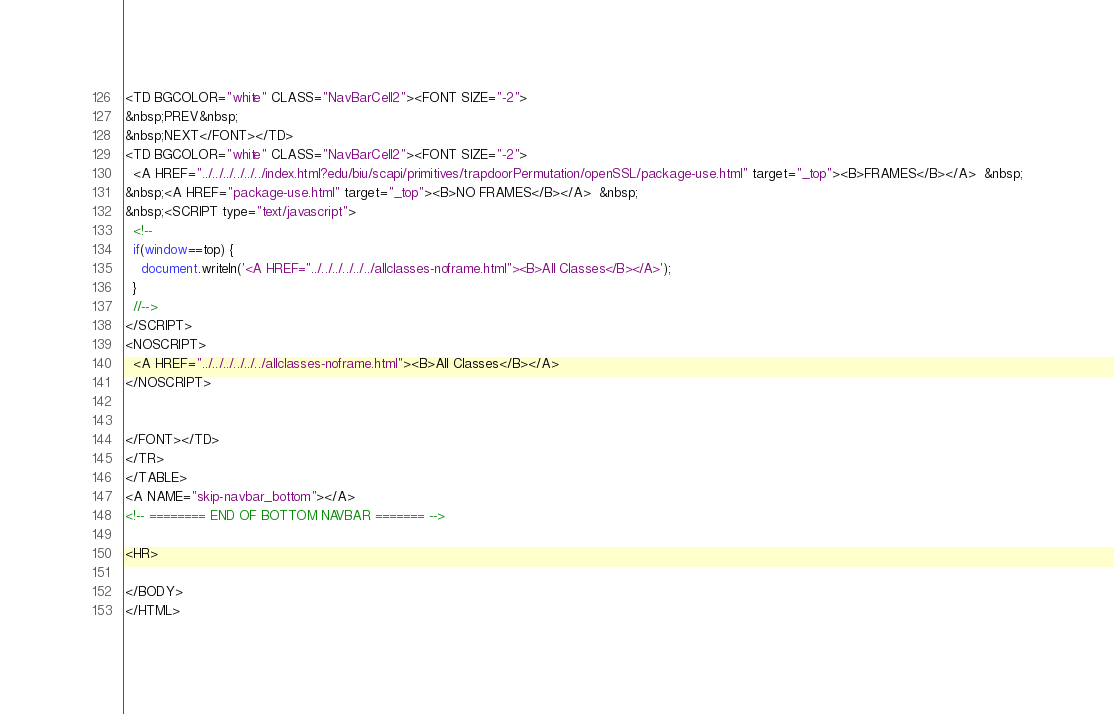<code> <loc_0><loc_0><loc_500><loc_500><_HTML_><TD BGCOLOR="white" CLASS="NavBarCell2"><FONT SIZE="-2">
&nbsp;PREV&nbsp;
&nbsp;NEXT</FONT></TD>
<TD BGCOLOR="white" CLASS="NavBarCell2"><FONT SIZE="-2">
  <A HREF="../../../../../../index.html?edu/biu/scapi/primitives/trapdoorPermutation/openSSL/package-use.html" target="_top"><B>FRAMES</B></A>  &nbsp;
&nbsp;<A HREF="package-use.html" target="_top"><B>NO FRAMES</B></A>  &nbsp;
&nbsp;<SCRIPT type="text/javascript">
  <!--
  if(window==top) {
    document.writeln('<A HREF="../../../../../../allclasses-noframe.html"><B>All Classes</B></A>');
  }
  //-->
</SCRIPT>
<NOSCRIPT>
  <A HREF="../../../../../../allclasses-noframe.html"><B>All Classes</B></A>
</NOSCRIPT>


</FONT></TD>
</TR>
</TABLE>
<A NAME="skip-navbar_bottom"></A>
<!-- ======== END OF BOTTOM NAVBAR ======= -->

<HR>

</BODY>
</HTML>
</code> 